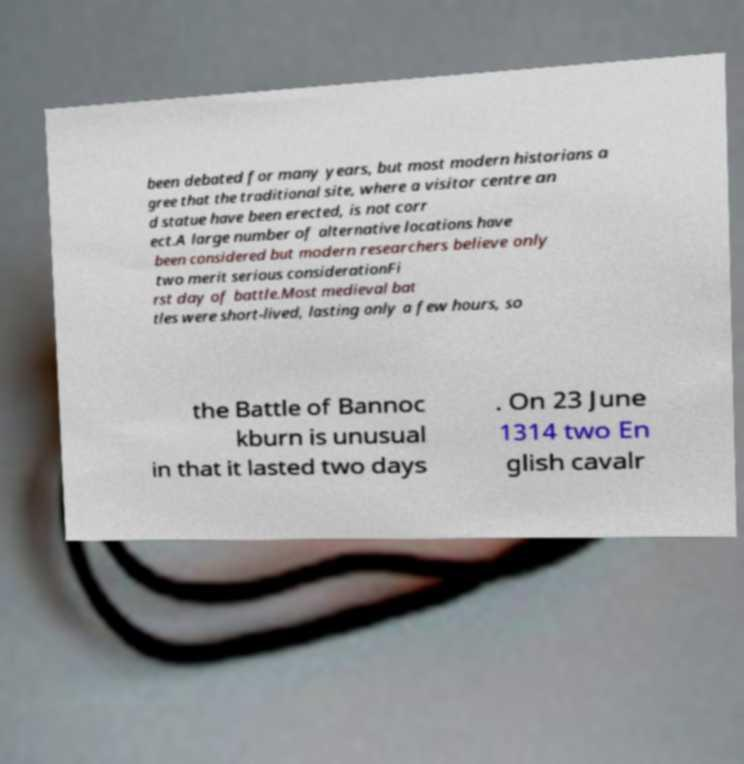Please identify and transcribe the text found in this image. been debated for many years, but most modern historians a gree that the traditional site, where a visitor centre an d statue have been erected, is not corr ect.A large number of alternative locations have been considered but modern researchers believe only two merit serious considerationFi rst day of battle.Most medieval bat tles were short-lived, lasting only a few hours, so the Battle of Bannoc kburn is unusual in that it lasted two days . On 23 June 1314 two En glish cavalr 